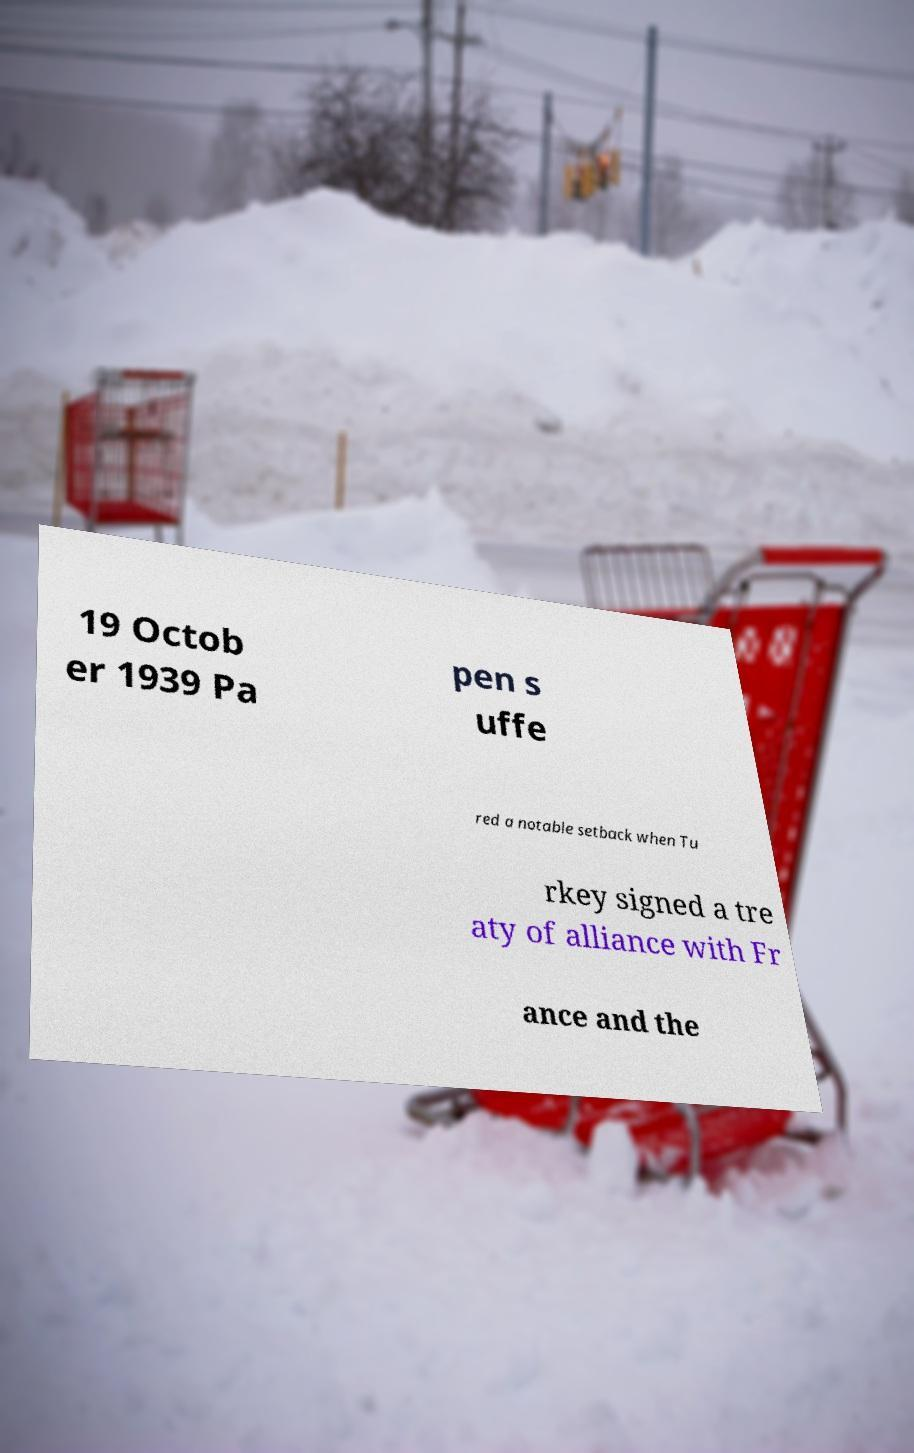I need the written content from this picture converted into text. Can you do that? 19 Octob er 1939 Pa pen s uffe red a notable setback when Tu rkey signed a tre aty of alliance with Fr ance and the 